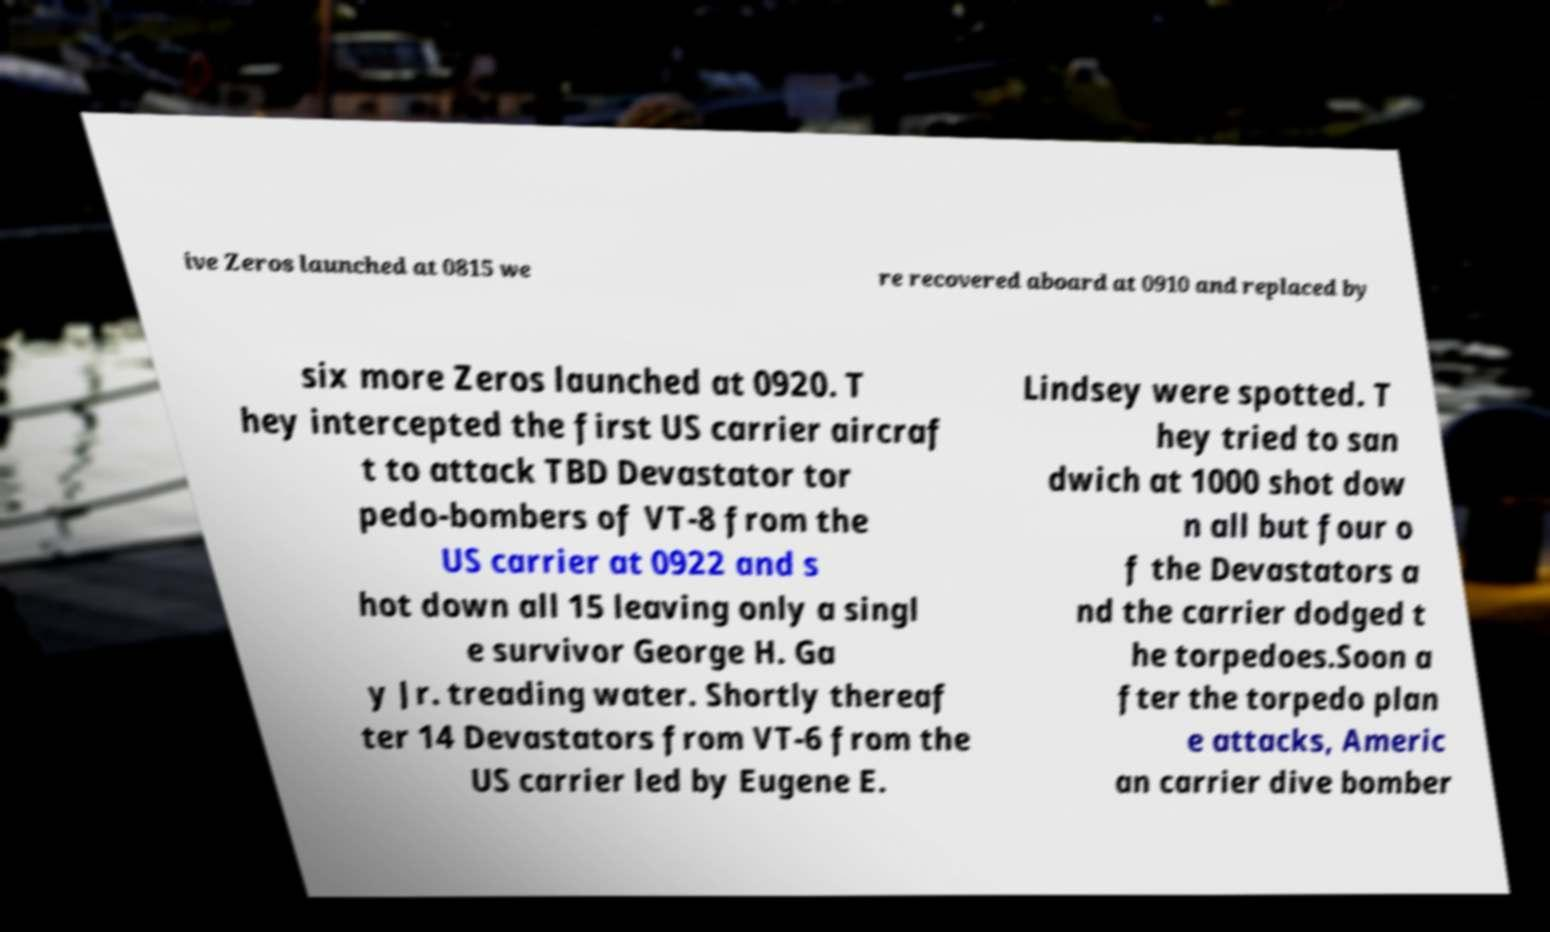Could you assist in decoding the text presented in this image and type it out clearly? ive Zeros launched at 0815 we re recovered aboard at 0910 and replaced by six more Zeros launched at 0920. T hey intercepted the first US carrier aircraf t to attack TBD Devastator tor pedo-bombers of VT-8 from the US carrier at 0922 and s hot down all 15 leaving only a singl e survivor George H. Ga y Jr. treading water. Shortly thereaf ter 14 Devastators from VT-6 from the US carrier led by Eugene E. Lindsey were spotted. T hey tried to san dwich at 1000 shot dow n all but four o f the Devastators a nd the carrier dodged t he torpedoes.Soon a fter the torpedo plan e attacks, Americ an carrier dive bomber 